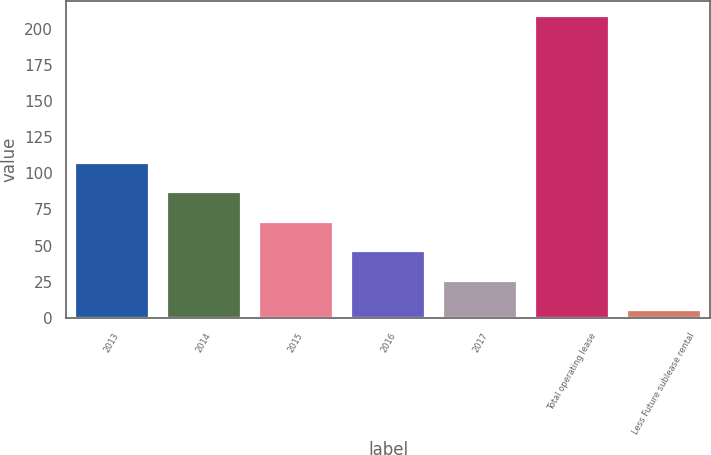Convert chart. <chart><loc_0><loc_0><loc_500><loc_500><bar_chart><fcel>2013<fcel>2014<fcel>2015<fcel>2016<fcel>2017<fcel>Total operating lease<fcel>Less Future sublease rental<nl><fcel>107.05<fcel>86.72<fcel>66.39<fcel>46.06<fcel>25.73<fcel>208.7<fcel>5.4<nl></chart> 